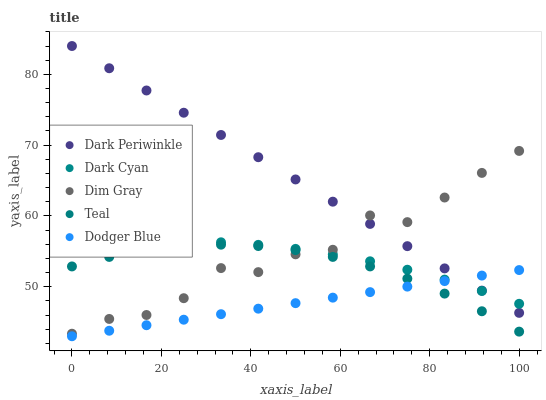Does Dodger Blue have the minimum area under the curve?
Answer yes or no. Yes. Does Dark Periwinkle have the maximum area under the curve?
Answer yes or no. Yes. Does Dim Gray have the minimum area under the curve?
Answer yes or no. No. Does Dim Gray have the maximum area under the curve?
Answer yes or no. No. Is Dodger Blue the smoothest?
Answer yes or no. Yes. Is Dim Gray the roughest?
Answer yes or no. Yes. Is Dim Gray the smoothest?
Answer yes or no. No. Is Dodger Blue the roughest?
Answer yes or no. No. Does Dodger Blue have the lowest value?
Answer yes or no. Yes. Does Dim Gray have the lowest value?
Answer yes or no. No. Does Dark Periwinkle have the highest value?
Answer yes or no. Yes. Does Dim Gray have the highest value?
Answer yes or no. No. Is Teal less than Dark Cyan?
Answer yes or no. Yes. Is Dark Periwinkle greater than Teal?
Answer yes or no. Yes. Does Dark Periwinkle intersect Dodger Blue?
Answer yes or no. Yes. Is Dark Periwinkle less than Dodger Blue?
Answer yes or no. No. Is Dark Periwinkle greater than Dodger Blue?
Answer yes or no. No. Does Teal intersect Dark Cyan?
Answer yes or no. No. 